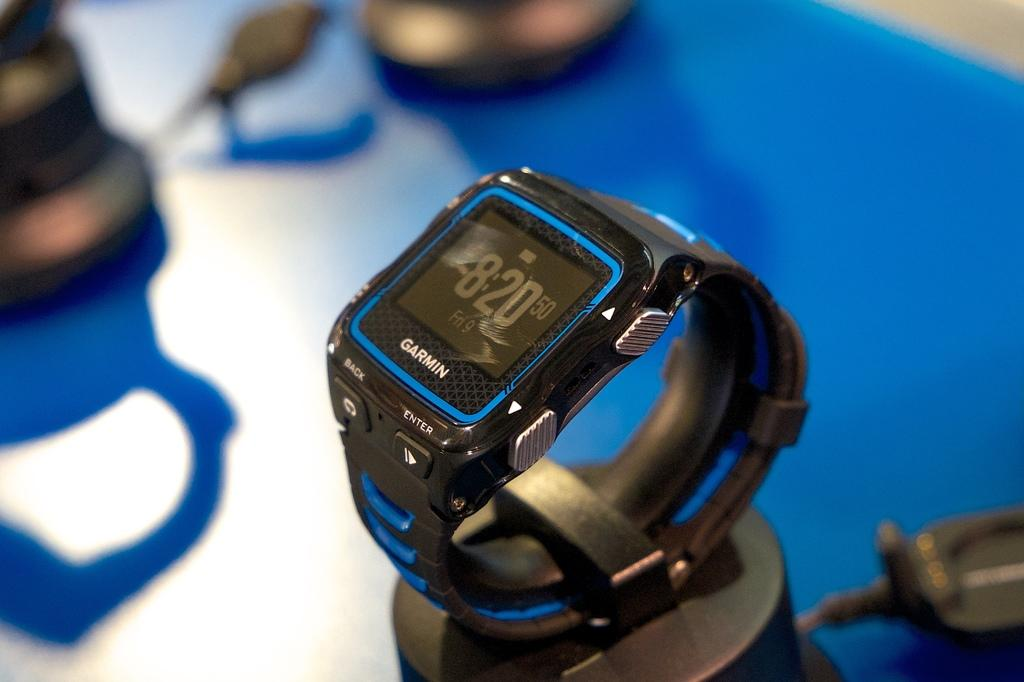<image>
Summarize the visual content of the image. A Garmin watch says that the time is 8:20. 